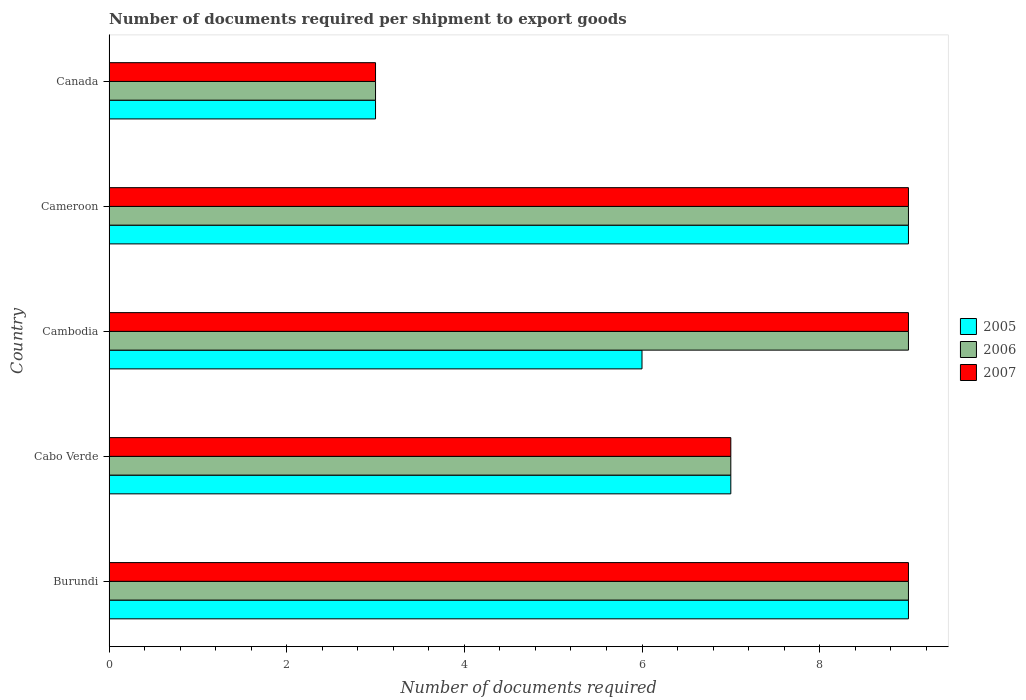How many different coloured bars are there?
Provide a short and direct response. 3. How many groups of bars are there?
Give a very brief answer. 5. How many bars are there on the 3rd tick from the top?
Offer a very short reply. 3. What is the label of the 4th group of bars from the top?
Keep it short and to the point. Cabo Verde. Across all countries, what is the maximum number of documents required per shipment to export goods in 2007?
Your response must be concise. 9. In which country was the number of documents required per shipment to export goods in 2007 maximum?
Provide a succinct answer. Burundi. In which country was the number of documents required per shipment to export goods in 2006 minimum?
Your answer should be compact. Canada. What is the difference between the number of documents required per shipment to export goods in 2007 in Cabo Verde and that in Cambodia?
Offer a terse response. -2. What is the average number of documents required per shipment to export goods in 2006 per country?
Your answer should be compact. 7.4. What is the difference between the number of documents required per shipment to export goods in 2006 and number of documents required per shipment to export goods in 2005 in Cameroon?
Provide a succinct answer. 0. In how many countries, is the number of documents required per shipment to export goods in 2006 greater than 8 ?
Ensure brevity in your answer.  3. Is the number of documents required per shipment to export goods in 2005 in Cambodia less than that in Canada?
Keep it short and to the point. No. Is the difference between the number of documents required per shipment to export goods in 2006 in Cameroon and Canada greater than the difference between the number of documents required per shipment to export goods in 2005 in Cameroon and Canada?
Your answer should be very brief. No. What is the difference between the highest and the lowest number of documents required per shipment to export goods in 2006?
Give a very brief answer. 6. Is the sum of the number of documents required per shipment to export goods in 2007 in Cabo Verde and Canada greater than the maximum number of documents required per shipment to export goods in 2005 across all countries?
Provide a succinct answer. Yes. What does the 2nd bar from the top in Cameroon represents?
Your answer should be compact. 2006. What does the 1st bar from the bottom in Canada represents?
Provide a succinct answer. 2005. How many bars are there?
Give a very brief answer. 15. Are the values on the major ticks of X-axis written in scientific E-notation?
Your response must be concise. No. Does the graph contain grids?
Offer a terse response. No. How are the legend labels stacked?
Offer a very short reply. Vertical. What is the title of the graph?
Offer a very short reply. Number of documents required per shipment to export goods. What is the label or title of the X-axis?
Keep it short and to the point. Number of documents required. What is the Number of documents required of 2005 in Burundi?
Offer a very short reply. 9. What is the Number of documents required of 2006 in Burundi?
Ensure brevity in your answer.  9. What is the Number of documents required of 2006 in Cambodia?
Your answer should be compact. 9. What is the Number of documents required of 2005 in Cameroon?
Keep it short and to the point. 9. What is the Number of documents required in 2006 in Canada?
Give a very brief answer. 3. What is the Number of documents required of 2007 in Canada?
Offer a terse response. 3. Across all countries, what is the maximum Number of documents required in 2007?
Give a very brief answer. 9. Across all countries, what is the minimum Number of documents required in 2006?
Make the answer very short. 3. Across all countries, what is the minimum Number of documents required of 2007?
Your answer should be compact. 3. What is the total Number of documents required of 2006 in the graph?
Offer a terse response. 37. What is the total Number of documents required of 2007 in the graph?
Your answer should be compact. 37. What is the difference between the Number of documents required of 2007 in Burundi and that in Cabo Verde?
Offer a very short reply. 2. What is the difference between the Number of documents required of 2005 in Burundi and that in Cambodia?
Make the answer very short. 3. What is the difference between the Number of documents required of 2007 in Burundi and that in Cambodia?
Your answer should be compact. 0. What is the difference between the Number of documents required in 2005 in Burundi and that in Cameroon?
Give a very brief answer. 0. What is the difference between the Number of documents required in 2006 in Burundi and that in Cameroon?
Keep it short and to the point. 0. What is the difference between the Number of documents required in 2006 in Burundi and that in Canada?
Provide a succinct answer. 6. What is the difference between the Number of documents required in 2005 in Cabo Verde and that in Cambodia?
Your answer should be very brief. 1. What is the difference between the Number of documents required in 2006 in Cabo Verde and that in Cambodia?
Give a very brief answer. -2. What is the difference between the Number of documents required in 2007 in Cabo Verde and that in Cambodia?
Your answer should be very brief. -2. What is the difference between the Number of documents required of 2006 in Cabo Verde and that in Cameroon?
Ensure brevity in your answer.  -2. What is the difference between the Number of documents required in 2005 in Cabo Verde and that in Canada?
Ensure brevity in your answer.  4. What is the difference between the Number of documents required in 2006 in Cabo Verde and that in Canada?
Ensure brevity in your answer.  4. What is the difference between the Number of documents required of 2005 in Cambodia and that in Canada?
Your answer should be compact. 3. What is the difference between the Number of documents required in 2006 in Cambodia and that in Canada?
Your response must be concise. 6. What is the difference between the Number of documents required of 2005 in Burundi and the Number of documents required of 2006 in Cabo Verde?
Ensure brevity in your answer.  2. What is the difference between the Number of documents required in 2005 in Burundi and the Number of documents required in 2007 in Cambodia?
Your response must be concise. 0. What is the difference between the Number of documents required in 2005 in Burundi and the Number of documents required in 2007 in Cameroon?
Keep it short and to the point. 0. What is the difference between the Number of documents required of 2006 in Burundi and the Number of documents required of 2007 in Cameroon?
Keep it short and to the point. 0. What is the difference between the Number of documents required in 2005 in Burundi and the Number of documents required in 2006 in Canada?
Give a very brief answer. 6. What is the difference between the Number of documents required of 2005 in Cabo Verde and the Number of documents required of 2006 in Cameroon?
Provide a succinct answer. -2. What is the difference between the Number of documents required of 2005 in Cabo Verde and the Number of documents required of 2007 in Cameroon?
Your answer should be very brief. -2. What is the difference between the Number of documents required in 2005 in Cabo Verde and the Number of documents required in 2006 in Canada?
Make the answer very short. 4. What is the difference between the Number of documents required of 2005 in Cambodia and the Number of documents required of 2007 in Canada?
Offer a terse response. 3. What is the difference between the Number of documents required in 2006 in Cambodia and the Number of documents required in 2007 in Canada?
Provide a short and direct response. 6. What is the difference between the Number of documents required of 2005 in Cameroon and the Number of documents required of 2007 in Canada?
Provide a short and direct response. 6. What is the difference between the Number of documents required of 2006 in Cameroon and the Number of documents required of 2007 in Canada?
Your answer should be very brief. 6. What is the average Number of documents required of 2005 per country?
Keep it short and to the point. 6.8. What is the average Number of documents required in 2006 per country?
Offer a terse response. 7.4. What is the difference between the Number of documents required of 2005 and Number of documents required of 2006 in Burundi?
Your answer should be compact. 0. What is the difference between the Number of documents required of 2006 and Number of documents required of 2007 in Burundi?
Make the answer very short. 0. What is the difference between the Number of documents required of 2005 and Number of documents required of 2006 in Cambodia?
Your answer should be compact. -3. What is the difference between the Number of documents required of 2005 and Number of documents required of 2007 in Cambodia?
Make the answer very short. -3. What is the difference between the Number of documents required of 2006 and Number of documents required of 2007 in Cambodia?
Keep it short and to the point. 0. What is the difference between the Number of documents required of 2005 and Number of documents required of 2007 in Cameroon?
Ensure brevity in your answer.  0. What is the difference between the Number of documents required in 2005 and Number of documents required in 2006 in Canada?
Provide a succinct answer. 0. What is the difference between the Number of documents required in 2005 and Number of documents required in 2007 in Canada?
Your response must be concise. 0. What is the ratio of the Number of documents required in 2005 in Burundi to that in Cambodia?
Offer a very short reply. 1.5. What is the ratio of the Number of documents required of 2007 in Burundi to that in Cameroon?
Provide a short and direct response. 1. What is the ratio of the Number of documents required of 2005 in Burundi to that in Canada?
Provide a short and direct response. 3. What is the ratio of the Number of documents required in 2006 in Burundi to that in Canada?
Keep it short and to the point. 3. What is the ratio of the Number of documents required of 2005 in Cabo Verde to that in Cambodia?
Provide a succinct answer. 1.17. What is the ratio of the Number of documents required of 2005 in Cabo Verde to that in Cameroon?
Offer a very short reply. 0.78. What is the ratio of the Number of documents required in 2005 in Cabo Verde to that in Canada?
Your response must be concise. 2.33. What is the ratio of the Number of documents required of 2006 in Cabo Verde to that in Canada?
Ensure brevity in your answer.  2.33. What is the ratio of the Number of documents required in 2007 in Cabo Verde to that in Canada?
Your answer should be very brief. 2.33. What is the ratio of the Number of documents required of 2005 in Cambodia to that in Cameroon?
Ensure brevity in your answer.  0.67. What is the ratio of the Number of documents required of 2007 in Cambodia to that in Canada?
Give a very brief answer. 3. What is the ratio of the Number of documents required of 2007 in Cameroon to that in Canada?
Your response must be concise. 3. What is the difference between the highest and the second highest Number of documents required in 2007?
Provide a succinct answer. 0. What is the difference between the highest and the lowest Number of documents required of 2007?
Ensure brevity in your answer.  6. 